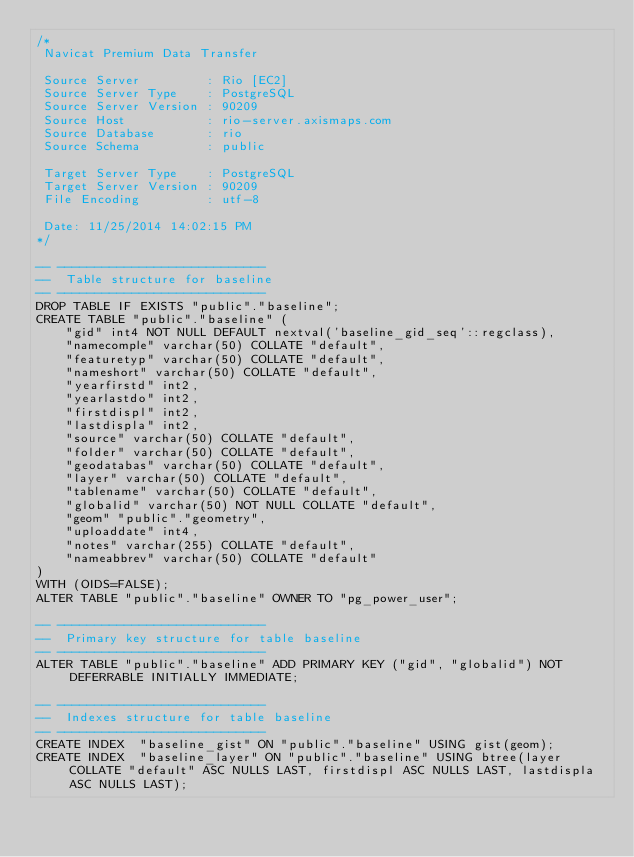<code> <loc_0><loc_0><loc_500><loc_500><_SQL_>/*
 Navicat Premium Data Transfer

 Source Server         : Rio [EC2]
 Source Server Type    : PostgreSQL
 Source Server Version : 90209
 Source Host           : rio-server.axismaps.com
 Source Database       : rio
 Source Schema         : public

 Target Server Type    : PostgreSQL
 Target Server Version : 90209
 File Encoding         : utf-8

 Date: 11/25/2014 14:02:15 PM
*/

-- ----------------------------
--  Table structure for baseline
-- ----------------------------
DROP TABLE IF EXISTS "public"."baseline";
CREATE TABLE "public"."baseline" (
	"gid" int4 NOT NULL DEFAULT nextval('baseline_gid_seq'::regclass),
	"namecomple" varchar(50) COLLATE "default",
	"featuretyp" varchar(50) COLLATE "default",
	"nameshort" varchar(50) COLLATE "default",
	"yearfirstd" int2,
	"yearlastdo" int2,
	"firstdispl" int2,
	"lastdispla" int2,
	"source" varchar(50) COLLATE "default",
	"folder" varchar(50) COLLATE "default",
	"geodatabas" varchar(50) COLLATE "default",
	"layer" varchar(50) COLLATE "default",
	"tablename" varchar(50) COLLATE "default",
	"globalid" varchar(50) NOT NULL COLLATE "default",
	"geom" "public"."geometry",
	"uploaddate" int4,
	"notes" varchar(255) COLLATE "default",
	"nameabbrev" varchar(50) COLLATE "default"
)
WITH (OIDS=FALSE);
ALTER TABLE "public"."baseline" OWNER TO "pg_power_user";

-- ----------------------------
--  Primary key structure for table baseline
-- ----------------------------
ALTER TABLE "public"."baseline" ADD PRIMARY KEY ("gid", "globalid") NOT DEFERRABLE INITIALLY IMMEDIATE;

-- ----------------------------
--  Indexes structure for table baseline
-- ----------------------------
CREATE INDEX  "baseline_gist" ON "public"."baseline" USING gist(geom);
CREATE INDEX  "baseline_layer" ON "public"."baseline" USING btree(layer COLLATE "default" ASC NULLS LAST, firstdispl ASC NULLS LAST, lastdispla ASC NULLS LAST);

</code> 